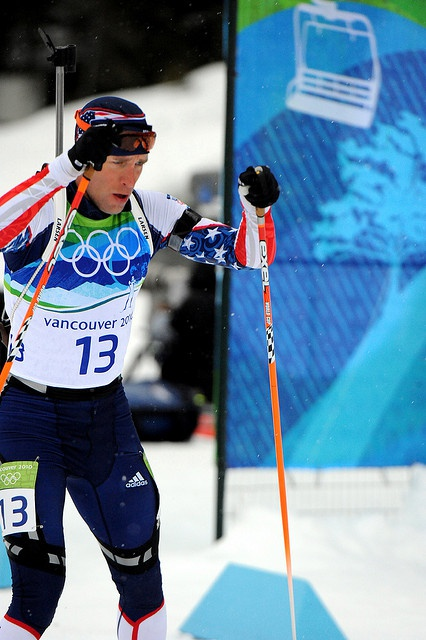Describe the objects in this image and their specific colors. I can see people in black, lavender, navy, and darkblue tones in this image. 